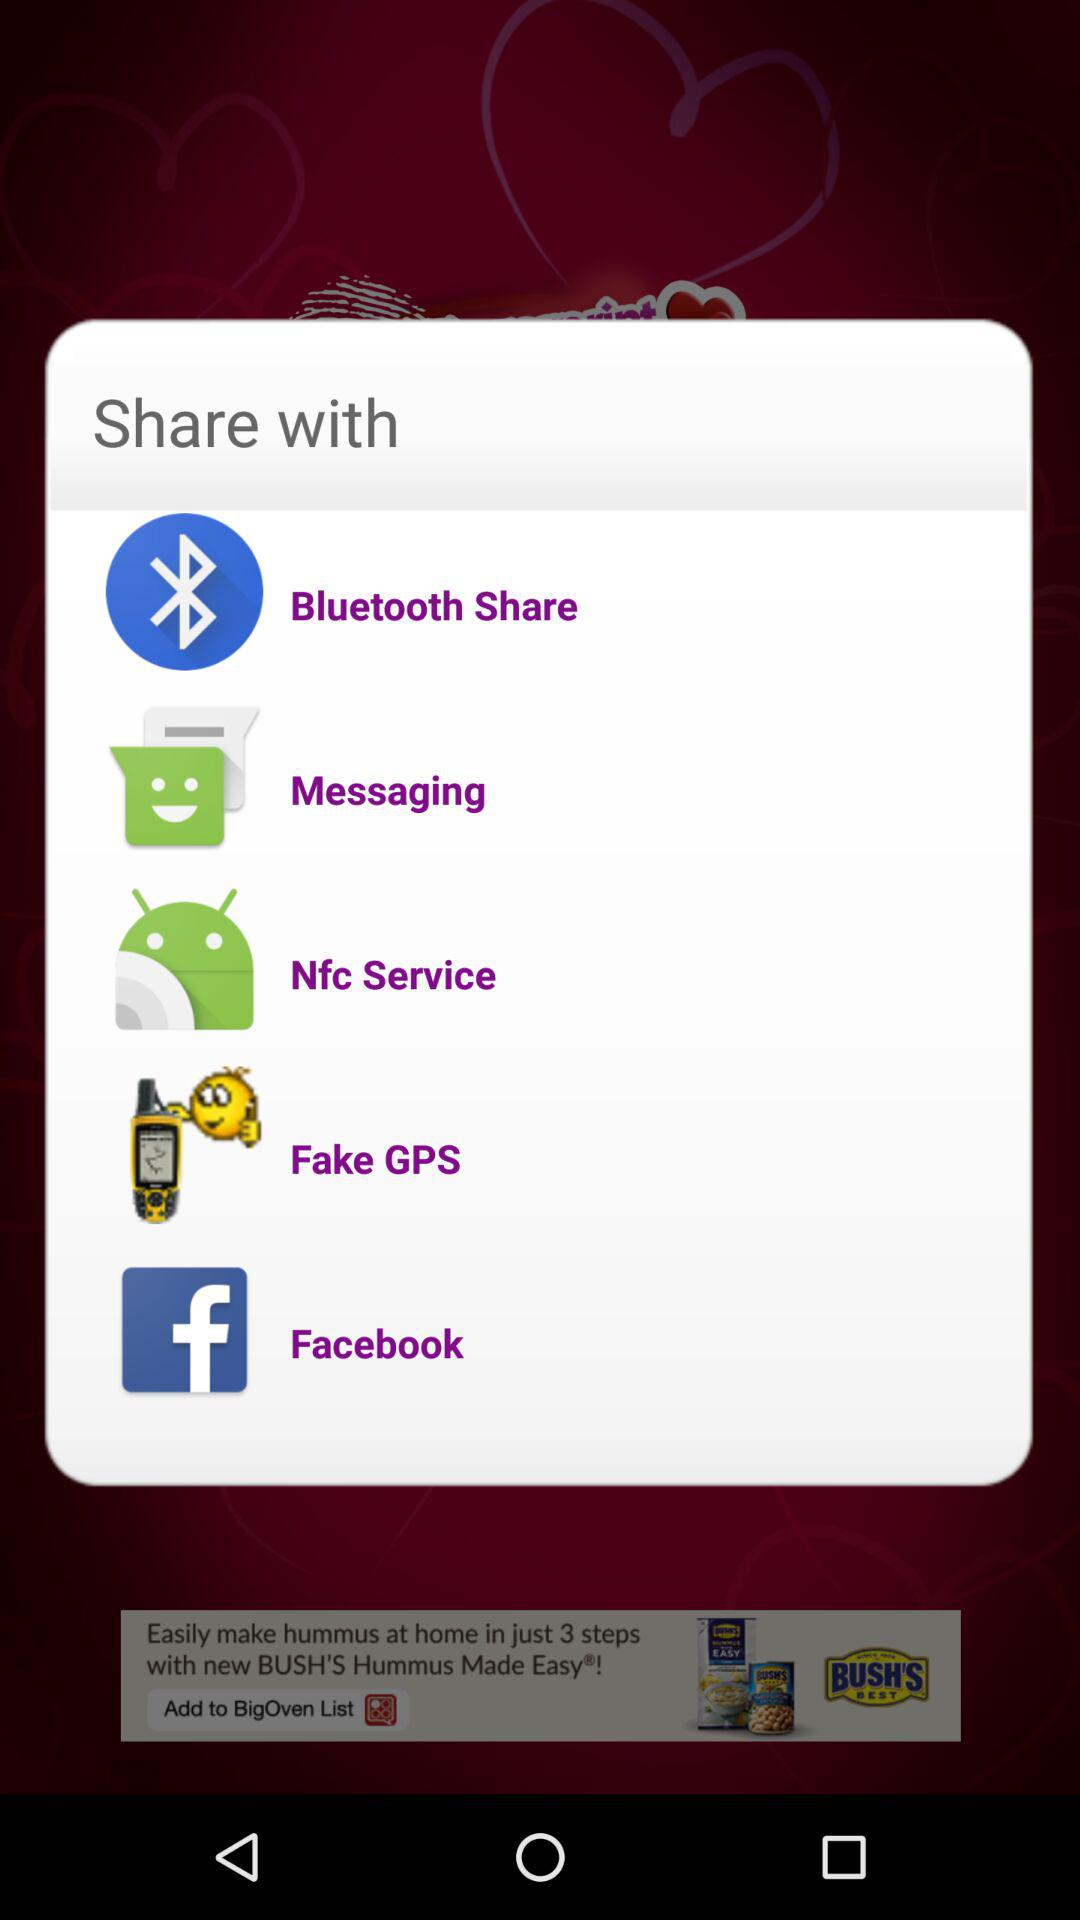What are the different applications through which we can share? The different applications through which we can share are "Bluetooth Share", "Messaging", "Nfc Service", "Fake GPS" and "Facebook". 